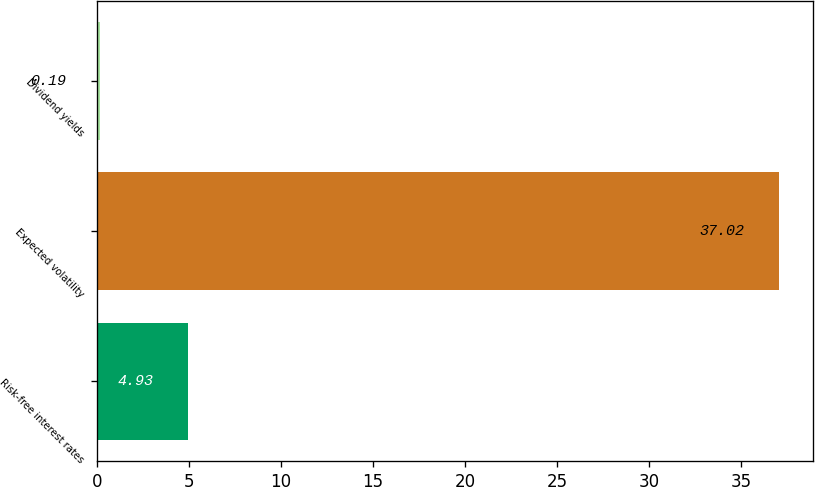<chart> <loc_0><loc_0><loc_500><loc_500><bar_chart><fcel>Risk-free interest rates<fcel>Expected volatility<fcel>Dividend yields<nl><fcel>4.93<fcel>37.02<fcel>0.19<nl></chart> 